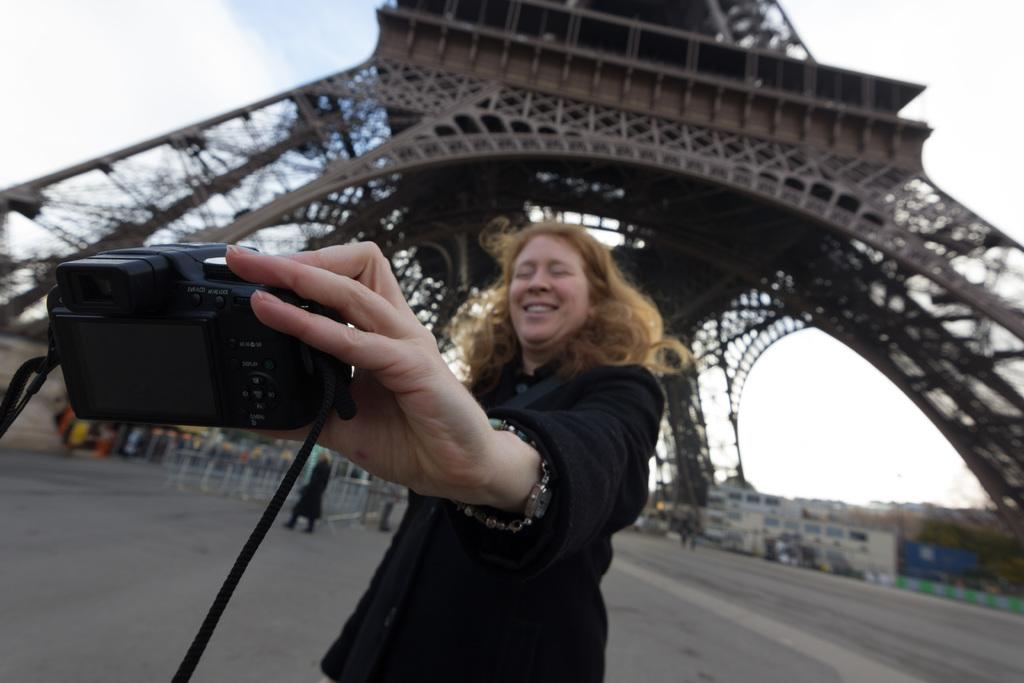Who is in the image? There is a woman in the image. What is the woman doing? The woman is smiling and holding a camera. What can be seen in the background of the image? There are people, a path, a tower, and the sky visible in the background. What type of silk fabric is draped over the tower in the image? There is no silk fabric present in the image; the tower is visible in the background without any fabric draped over it. 